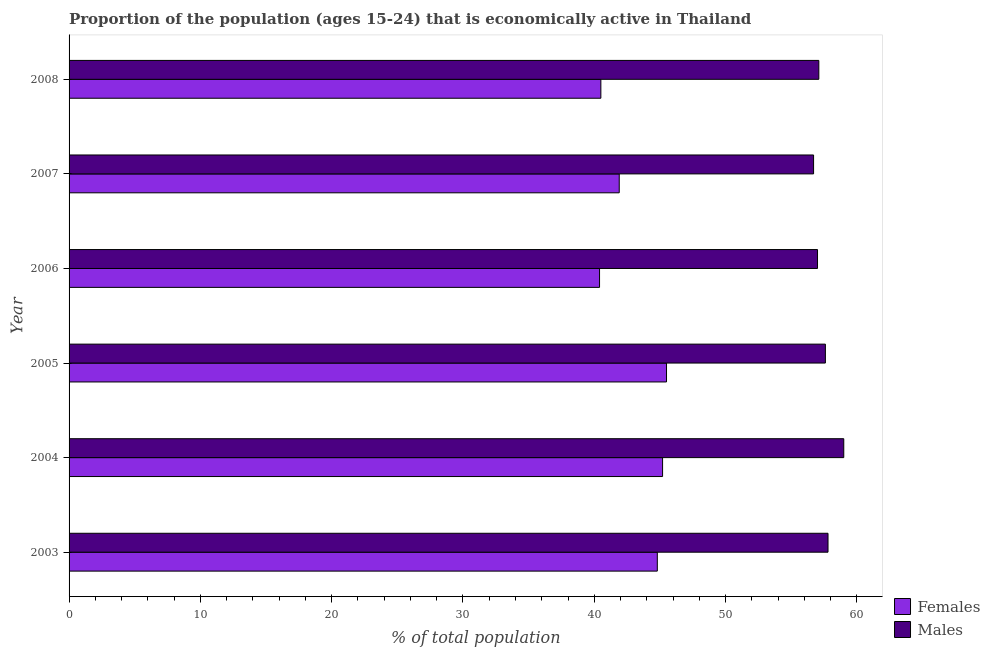How many different coloured bars are there?
Keep it short and to the point. 2. How many groups of bars are there?
Keep it short and to the point. 6. Are the number of bars per tick equal to the number of legend labels?
Your answer should be very brief. Yes. Are the number of bars on each tick of the Y-axis equal?
Offer a very short reply. Yes. How many bars are there on the 1st tick from the top?
Keep it short and to the point. 2. How many bars are there on the 6th tick from the bottom?
Provide a succinct answer. 2. What is the label of the 1st group of bars from the top?
Ensure brevity in your answer.  2008. In how many cases, is the number of bars for a given year not equal to the number of legend labels?
Give a very brief answer. 0. What is the percentage of economically active male population in 2008?
Provide a short and direct response. 57.1. Across all years, what is the maximum percentage of economically active female population?
Your answer should be very brief. 45.5. Across all years, what is the minimum percentage of economically active female population?
Provide a short and direct response. 40.4. In which year was the percentage of economically active male population maximum?
Your answer should be very brief. 2004. In which year was the percentage of economically active male population minimum?
Offer a terse response. 2007. What is the total percentage of economically active female population in the graph?
Offer a terse response. 258.3. What is the difference between the percentage of economically active female population in 2003 and that in 2008?
Offer a very short reply. 4.3. What is the difference between the percentage of economically active male population in 2003 and the percentage of economically active female population in 2004?
Your answer should be very brief. 12.6. What is the average percentage of economically active male population per year?
Provide a short and direct response. 57.53. What is the ratio of the percentage of economically active female population in 2004 to that in 2008?
Your response must be concise. 1.12. What is the difference between the highest and the second highest percentage of economically active male population?
Provide a short and direct response. 1.2. What does the 1st bar from the top in 2005 represents?
Provide a succinct answer. Males. What does the 2nd bar from the bottom in 2003 represents?
Your answer should be very brief. Males. How many bars are there?
Your answer should be very brief. 12. Are all the bars in the graph horizontal?
Provide a succinct answer. Yes. How many years are there in the graph?
Keep it short and to the point. 6. What is the difference between two consecutive major ticks on the X-axis?
Your answer should be very brief. 10. Are the values on the major ticks of X-axis written in scientific E-notation?
Ensure brevity in your answer.  No. Does the graph contain any zero values?
Offer a very short reply. No. Does the graph contain grids?
Ensure brevity in your answer.  No. How are the legend labels stacked?
Make the answer very short. Vertical. What is the title of the graph?
Provide a short and direct response. Proportion of the population (ages 15-24) that is economically active in Thailand. Does "Commercial service imports" appear as one of the legend labels in the graph?
Provide a succinct answer. No. What is the label or title of the X-axis?
Ensure brevity in your answer.  % of total population. What is the % of total population in Females in 2003?
Your answer should be compact. 44.8. What is the % of total population of Males in 2003?
Your answer should be very brief. 57.8. What is the % of total population in Females in 2004?
Your answer should be compact. 45.2. What is the % of total population of Females in 2005?
Give a very brief answer. 45.5. What is the % of total population in Males in 2005?
Give a very brief answer. 57.6. What is the % of total population in Females in 2006?
Ensure brevity in your answer.  40.4. What is the % of total population in Males in 2006?
Keep it short and to the point. 57. What is the % of total population in Females in 2007?
Make the answer very short. 41.9. What is the % of total population of Males in 2007?
Provide a short and direct response. 56.7. What is the % of total population in Females in 2008?
Your answer should be compact. 40.5. What is the % of total population in Males in 2008?
Provide a succinct answer. 57.1. Across all years, what is the maximum % of total population in Females?
Make the answer very short. 45.5. Across all years, what is the minimum % of total population in Females?
Keep it short and to the point. 40.4. Across all years, what is the minimum % of total population of Males?
Provide a short and direct response. 56.7. What is the total % of total population of Females in the graph?
Your answer should be compact. 258.3. What is the total % of total population of Males in the graph?
Offer a terse response. 345.2. What is the difference between the % of total population of Females in 2003 and that in 2004?
Offer a terse response. -0.4. What is the difference between the % of total population in Males in 2003 and that in 2004?
Offer a very short reply. -1.2. What is the difference between the % of total population in Females in 2003 and that in 2005?
Your response must be concise. -0.7. What is the difference between the % of total population in Females in 2003 and that in 2007?
Give a very brief answer. 2.9. What is the difference between the % of total population in Males in 2003 and that in 2008?
Provide a short and direct response. 0.7. What is the difference between the % of total population of Males in 2004 and that in 2005?
Your response must be concise. 1.4. What is the difference between the % of total population in Males in 2004 and that in 2006?
Your answer should be very brief. 2. What is the difference between the % of total population of Females in 2004 and that in 2008?
Make the answer very short. 4.7. What is the difference between the % of total population of Females in 2005 and that in 2007?
Provide a short and direct response. 3.6. What is the difference between the % of total population of Males in 2005 and that in 2007?
Offer a terse response. 0.9. What is the difference between the % of total population in Males in 2006 and that in 2007?
Offer a very short reply. 0.3. What is the difference between the % of total population in Females in 2003 and the % of total population in Males in 2008?
Offer a very short reply. -12.3. What is the difference between the % of total population of Females in 2004 and the % of total population of Males in 2005?
Your answer should be very brief. -12.4. What is the difference between the % of total population of Females in 2004 and the % of total population of Males in 2006?
Your answer should be very brief. -11.8. What is the difference between the % of total population of Females in 2004 and the % of total population of Males in 2007?
Give a very brief answer. -11.5. What is the difference between the % of total population in Females in 2004 and the % of total population in Males in 2008?
Offer a terse response. -11.9. What is the difference between the % of total population of Females in 2005 and the % of total population of Males in 2006?
Give a very brief answer. -11.5. What is the difference between the % of total population of Females in 2005 and the % of total population of Males in 2008?
Offer a very short reply. -11.6. What is the difference between the % of total population in Females in 2006 and the % of total population in Males in 2007?
Provide a succinct answer. -16.3. What is the difference between the % of total population of Females in 2006 and the % of total population of Males in 2008?
Keep it short and to the point. -16.7. What is the difference between the % of total population of Females in 2007 and the % of total population of Males in 2008?
Your response must be concise. -15.2. What is the average % of total population in Females per year?
Your response must be concise. 43.05. What is the average % of total population in Males per year?
Offer a very short reply. 57.53. In the year 2003, what is the difference between the % of total population of Females and % of total population of Males?
Offer a very short reply. -13. In the year 2005, what is the difference between the % of total population of Females and % of total population of Males?
Keep it short and to the point. -12.1. In the year 2006, what is the difference between the % of total population in Females and % of total population in Males?
Keep it short and to the point. -16.6. In the year 2007, what is the difference between the % of total population in Females and % of total population in Males?
Ensure brevity in your answer.  -14.8. In the year 2008, what is the difference between the % of total population of Females and % of total population of Males?
Provide a short and direct response. -16.6. What is the ratio of the % of total population in Males in 2003 to that in 2004?
Give a very brief answer. 0.98. What is the ratio of the % of total population in Females in 2003 to that in 2005?
Your answer should be compact. 0.98. What is the ratio of the % of total population of Females in 2003 to that in 2006?
Your answer should be very brief. 1.11. What is the ratio of the % of total population in Males in 2003 to that in 2006?
Provide a succinct answer. 1.01. What is the ratio of the % of total population in Females in 2003 to that in 2007?
Ensure brevity in your answer.  1.07. What is the ratio of the % of total population in Males in 2003 to that in 2007?
Provide a succinct answer. 1.02. What is the ratio of the % of total population in Females in 2003 to that in 2008?
Keep it short and to the point. 1.11. What is the ratio of the % of total population in Males in 2003 to that in 2008?
Offer a terse response. 1.01. What is the ratio of the % of total population in Females in 2004 to that in 2005?
Offer a very short reply. 0.99. What is the ratio of the % of total population in Males in 2004 to that in 2005?
Provide a short and direct response. 1.02. What is the ratio of the % of total population in Females in 2004 to that in 2006?
Offer a very short reply. 1.12. What is the ratio of the % of total population in Males in 2004 to that in 2006?
Keep it short and to the point. 1.04. What is the ratio of the % of total population of Females in 2004 to that in 2007?
Your answer should be very brief. 1.08. What is the ratio of the % of total population in Males in 2004 to that in 2007?
Your response must be concise. 1.04. What is the ratio of the % of total population in Females in 2004 to that in 2008?
Ensure brevity in your answer.  1.12. What is the ratio of the % of total population of Females in 2005 to that in 2006?
Keep it short and to the point. 1.13. What is the ratio of the % of total population in Males in 2005 to that in 2006?
Ensure brevity in your answer.  1.01. What is the ratio of the % of total population in Females in 2005 to that in 2007?
Your response must be concise. 1.09. What is the ratio of the % of total population of Males in 2005 to that in 2007?
Your answer should be very brief. 1.02. What is the ratio of the % of total population in Females in 2005 to that in 2008?
Your answer should be compact. 1.12. What is the ratio of the % of total population in Males in 2005 to that in 2008?
Keep it short and to the point. 1.01. What is the ratio of the % of total population in Females in 2006 to that in 2007?
Offer a very short reply. 0.96. What is the ratio of the % of total population in Females in 2006 to that in 2008?
Your answer should be very brief. 1. What is the ratio of the % of total population in Females in 2007 to that in 2008?
Provide a short and direct response. 1.03. What is the ratio of the % of total population in Males in 2007 to that in 2008?
Offer a very short reply. 0.99. What is the difference between the highest and the lowest % of total population of Males?
Your response must be concise. 2.3. 